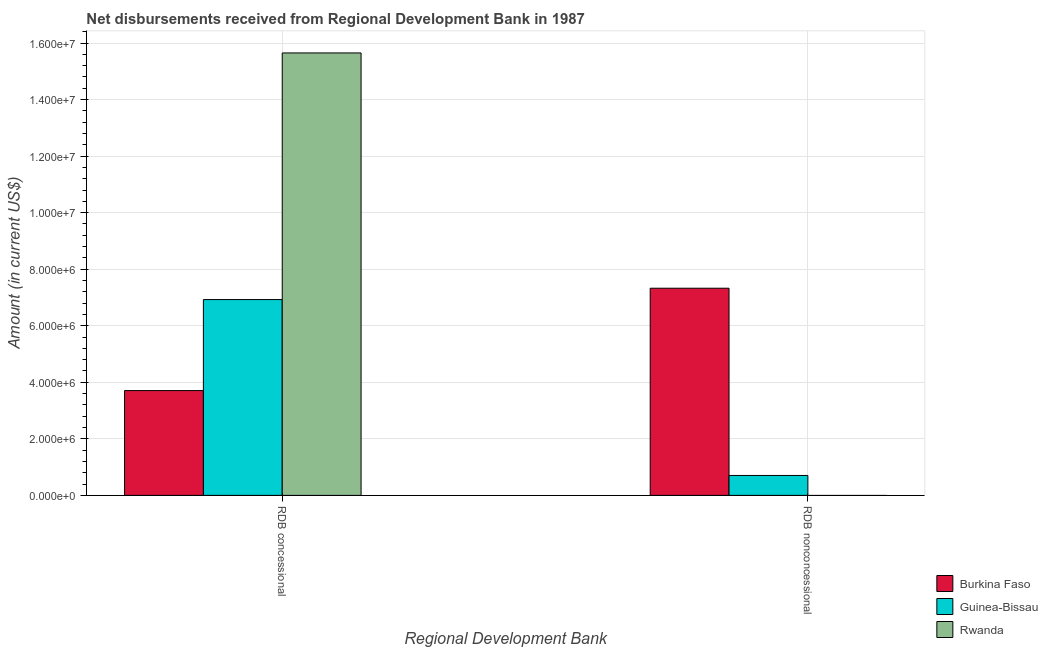How many groups of bars are there?
Your response must be concise. 2. Are the number of bars on each tick of the X-axis equal?
Offer a very short reply. No. How many bars are there on the 2nd tick from the right?
Offer a very short reply. 3. What is the label of the 2nd group of bars from the left?
Make the answer very short. RDB nonconcessional. What is the net concessional disbursements from rdb in Guinea-Bissau?
Ensure brevity in your answer.  6.93e+06. Across all countries, what is the maximum net non concessional disbursements from rdb?
Your answer should be very brief. 7.33e+06. Across all countries, what is the minimum net non concessional disbursements from rdb?
Give a very brief answer. 0. In which country was the net concessional disbursements from rdb maximum?
Your answer should be very brief. Rwanda. What is the total net concessional disbursements from rdb in the graph?
Provide a short and direct response. 2.63e+07. What is the difference between the net non concessional disbursements from rdb in Guinea-Bissau and that in Burkina Faso?
Ensure brevity in your answer.  -6.62e+06. What is the difference between the net non concessional disbursements from rdb in Guinea-Bissau and the net concessional disbursements from rdb in Rwanda?
Your answer should be very brief. -1.49e+07. What is the average net non concessional disbursements from rdb per country?
Ensure brevity in your answer.  2.68e+06. What is the difference between the net non concessional disbursements from rdb and net concessional disbursements from rdb in Guinea-Bissau?
Give a very brief answer. -6.22e+06. In how many countries, is the net non concessional disbursements from rdb greater than 15200000 US$?
Offer a terse response. 0. What is the ratio of the net concessional disbursements from rdb in Guinea-Bissau to that in Rwanda?
Make the answer very short. 0.44. Is the net concessional disbursements from rdb in Rwanda less than that in Burkina Faso?
Provide a short and direct response. No. How many countries are there in the graph?
Keep it short and to the point. 3. What is the difference between two consecutive major ticks on the Y-axis?
Provide a short and direct response. 2.00e+06. Does the graph contain any zero values?
Keep it short and to the point. Yes. Does the graph contain grids?
Give a very brief answer. Yes. How are the legend labels stacked?
Your answer should be compact. Vertical. What is the title of the graph?
Make the answer very short. Net disbursements received from Regional Development Bank in 1987. Does "Estonia" appear as one of the legend labels in the graph?
Make the answer very short. No. What is the label or title of the X-axis?
Ensure brevity in your answer.  Regional Development Bank. What is the label or title of the Y-axis?
Provide a succinct answer. Amount (in current US$). What is the Amount (in current US$) of Burkina Faso in RDB concessional?
Ensure brevity in your answer.  3.71e+06. What is the Amount (in current US$) in Guinea-Bissau in RDB concessional?
Provide a succinct answer. 6.93e+06. What is the Amount (in current US$) in Rwanda in RDB concessional?
Make the answer very short. 1.56e+07. What is the Amount (in current US$) of Burkina Faso in RDB nonconcessional?
Your answer should be very brief. 7.33e+06. What is the Amount (in current US$) in Guinea-Bissau in RDB nonconcessional?
Keep it short and to the point. 7.05e+05. What is the Amount (in current US$) in Rwanda in RDB nonconcessional?
Ensure brevity in your answer.  0. Across all Regional Development Bank, what is the maximum Amount (in current US$) of Burkina Faso?
Your response must be concise. 7.33e+06. Across all Regional Development Bank, what is the maximum Amount (in current US$) in Guinea-Bissau?
Provide a short and direct response. 6.93e+06. Across all Regional Development Bank, what is the maximum Amount (in current US$) in Rwanda?
Provide a succinct answer. 1.56e+07. Across all Regional Development Bank, what is the minimum Amount (in current US$) in Burkina Faso?
Provide a short and direct response. 3.71e+06. Across all Regional Development Bank, what is the minimum Amount (in current US$) in Guinea-Bissau?
Your answer should be very brief. 7.05e+05. Across all Regional Development Bank, what is the minimum Amount (in current US$) in Rwanda?
Your answer should be compact. 0. What is the total Amount (in current US$) in Burkina Faso in the graph?
Your response must be concise. 1.10e+07. What is the total Amount (in current US$) of Guinea-Bissau in the graph?
Keep it short and to the point. 7.63e+06. What is the total Amount (in current US$) in Rwanda in the graph?
Ensure brevity in your answer.  1.56e+07. What is the difference between the Amount (in current US$) of Burkina Faso in RDB concessional and that in RDB nonconcessional?
Keep it short and to the point. -3.62e+06. What is the difference between the Amount (in current US$) of Guinea-Bissau in RDB concessional and that in RDB nonconcessional?
Your answer should be very brief. 6.22e+06. What is the difference between the Amount (in current US$) in Burkina Faso in RDB concessional and the Amount (in current US$) in Guinea-Bissau in RDB nonconcessional?
Your response must be concise. 3.00e+06. What is the average Amount (in current US$) in Burkina Faso per Regional Development Bank?
Make the answer very short. 5.52e+06. What is the average Amount (in current US$) in Guinea-Bissau per Regional Development Bank?
Your answer should be very brief. 3.82e+06. What is the average Amount (in current US$) of Rwanda per Regional Development Bank?
Your answer should be compact. 7.82e+06. What is the difference between the Amount (in current US$) in Burkina Faso and Amount (in current US$) in Guinea-Bissau in RDB concessional?
Keep it short and to the point. -3.22e+06. What is the difference between the Amount (in current US$) of Burkina Faso and Amount (in current US$) of Rwanda in RDB concessional?
Keep it short and to the point. -1.19e+07. What is the difference between the Amount (in current US$) of Guinea-Bissau and Amount (in current US$) of Rwanda in RDB concessional?
Your response must be concise. -8.72e+06. What is the difference between the Amount (in current US$) of Burkina Faso and Amount (in current US$) of Guinea-Bissau in RDB nonconcessional?
Ensure brevity in your answer.  6.62e+06. What is the ratio of the Amount (in current US$) in Burkina Faso in RDB concessional to that in RDB nonconcessional?
Offer a very short reply. 0.51. What is the ratio of the Amount (in current US$) in Guinea-Bissau in RDB concessional to that in RDB nonconcessional?
Offer a very short reply. 9.82. What is the difference between the highest and the second highest Amount (in current US$) of Burkina Faso?
Provide a succinct answer. 3.62e+06. What is the difference between the highest and the second highest Amount (in current US$) of Guinea-Bissau?
Offer a very short reply. 6.22e+06. What is the difference between the highest and the lowest Amount (in current US$) of Burkina Faso?
Keep it short and to the point. 3.62e+06. What is the difference between the highest and the lowest Amount (in current US$) in Guinea-Bissau?
Offer a very short reply. 6.22e+06. What is the difference between the highest and the lowest Amount (in current US$) in Rwanda?
Ensure brevity in your answer.  1.56e+07. 